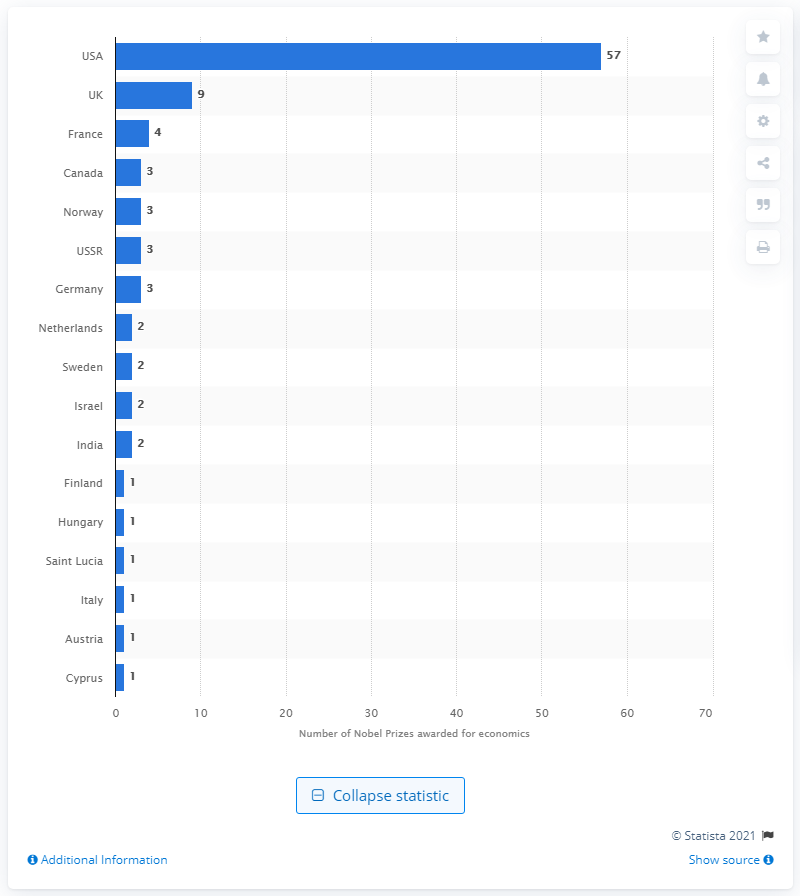Outline some significant characteristics in this image. Americans have won the Nobel Prize in economics 57 times. 